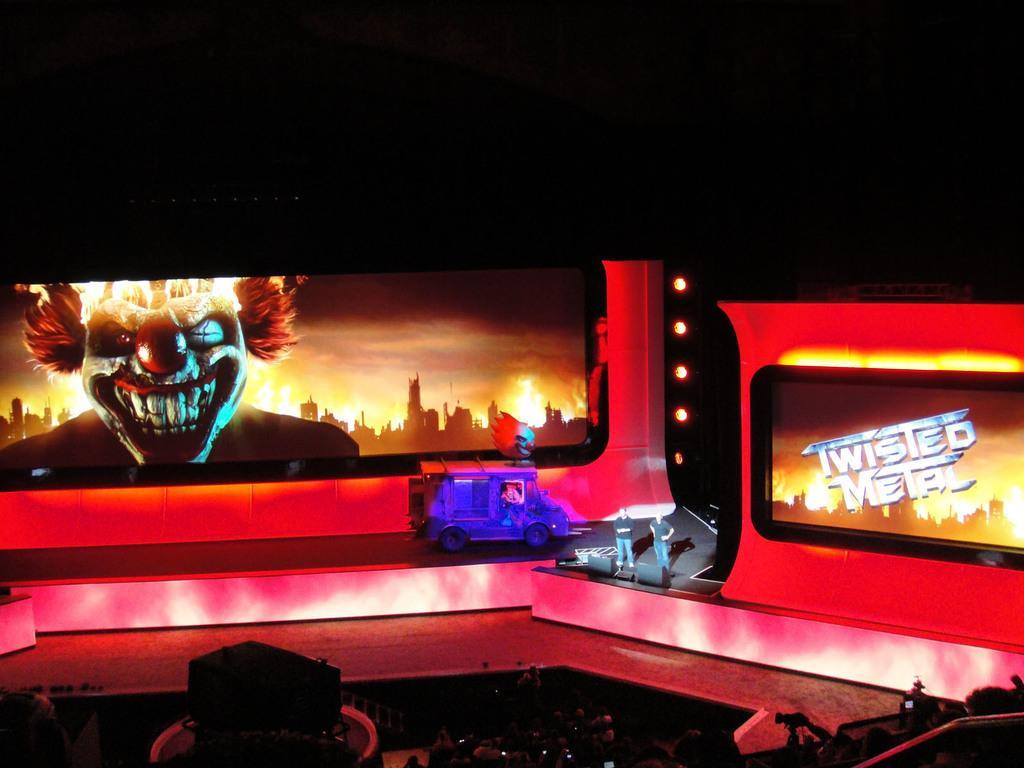Describe this image in one or two sentences. This picture might be taken in a concert, in this image at the bottom there are a group of people sitting and some of them are holding cameras and mobiles and there is some object. In the center there are two persons standing and one vehicle, and in the background there are screens and stage. At the top of the image there is black color. 